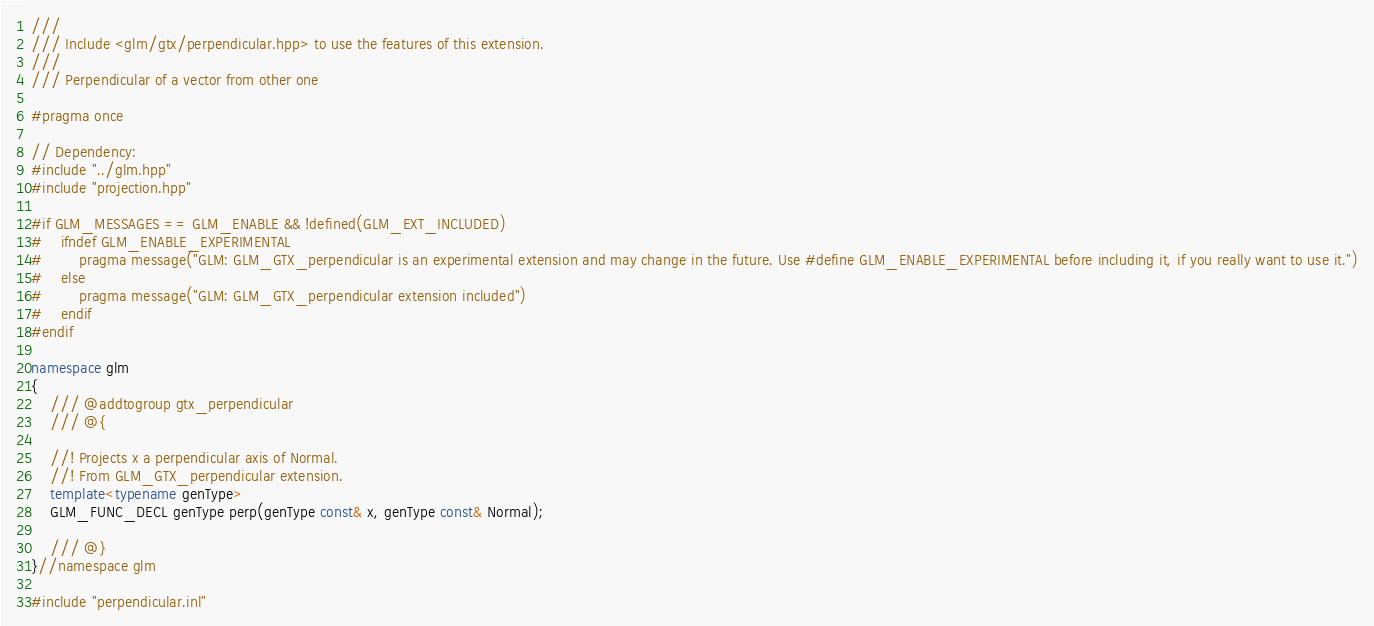Convert code to text. <code><loc_0><loc_0><loc_500><loc_500><_C++_>///
/// Include <glm/gtx/perpendicular.hpp> to use the features of this extension.
///
/// Perpendicular of a vector from other one

#pragma once

// Dependency:
#include "../glm.hpp"
#include "projection.hpp"

#if GLM_MESSAGES == GLM_ENABLE && !defined(GLM_EXT_INCLUDED)
#	ifndef GLM_ENABLE_EXPERIMENTAL
#		pragma message("GLM: GLM_GTX_perpendicular is an experimental extension and may change in the future. Use #define GLM_ENABLE_EXPERIMENTAL before including it, if you really want to use it.")
#	else
#		pragma message("GLM: GLM_GTX_perpendicular extension included")
#	endif
#endif

namespace glm
{
	/// @addtogroup gtx_perpendicular
	/// @{

	//! Projects x a perpendicular axis of Normal.
	//! From GLM_GTX_perpendicular extension.
	template<typename genType>
	GLM_FUNC_DECL genType perp(genType const& x, genType const& Normal);

	/// @}
}//namespace glm

#include "perpendicular.inl"
</code> 